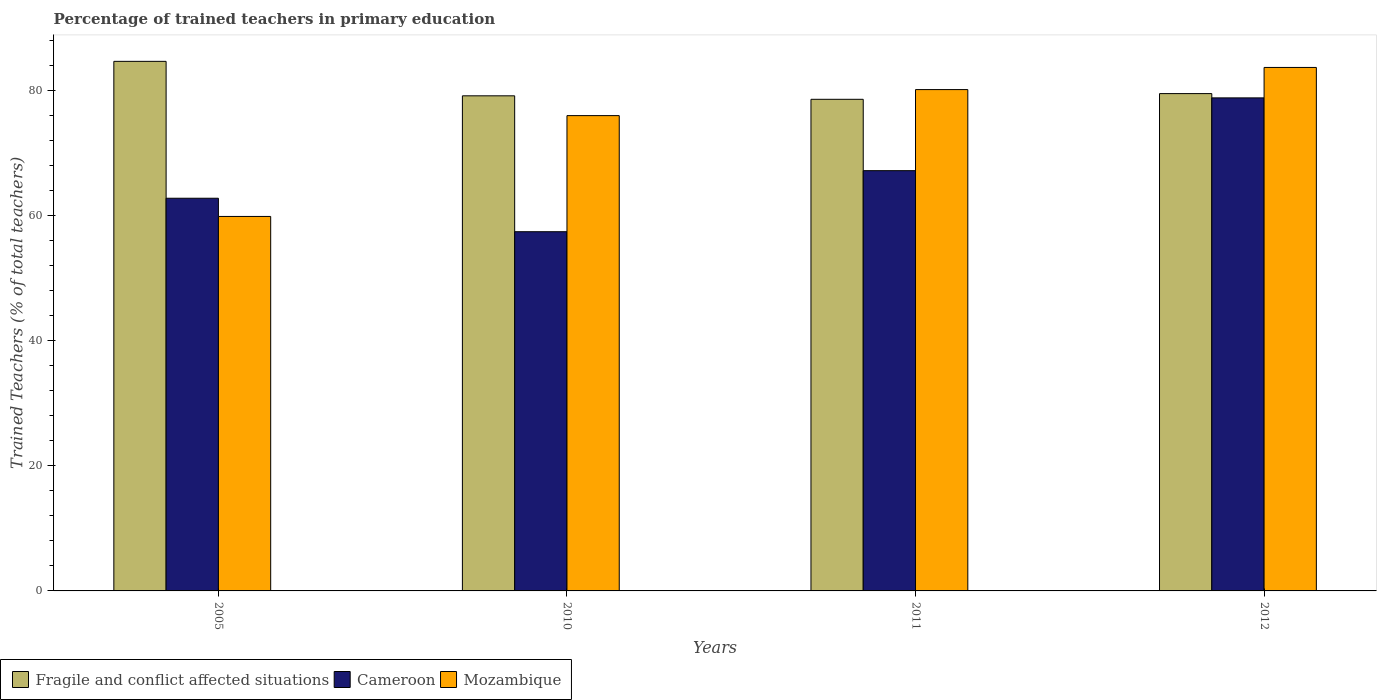How many bars are there on the 2nd tick from the left?
Provide a short and direct response. 3. In how many cases, is the number of bars for a given year not equal to the number of legend labels?
Your response must be concise. 0. What is the percentage of trained teachers in Cameroon in 2005?
Keep it short and to the point. 62.74. Across all years, what is the maximum percentage of trained teachers in Mozambique?
Your response must be concise. 83.64. Across all years, what is the minimum percentage of trained teachers in Fragile and conflict affected situations?
Offer a very short reply. 78.55. In which year was the percentage of trained teachers in Fragile and conflict affected situations minimum?
Offer a terse response. 2011. What is the total percentage of trained teachers in Cameroon in the graph?
Keep it short and to the point. 266.06. What is the difference between the percentage of trained teachers in Fragile and conflict affected situations in 2011 and that in 2012?
Offer a very short reply. -0.91. What is the difference between the percentage of trained teachers in Fragile and conflict affected situations in 2010 and the percentage of trained teachers in Mozambique in 2005?
Offer a terse response. 19.27. What is the average percentage of trained teachers in Mozambique per year?
Provide a short and direct response. 74.88. In the year 2010, what is the difference between the percentage of trained teachers in Mozambique and percentage of trained teachers in Cameroon?
Give a very brief answer. 18.55. In how many years, is the percentage of trained teachers in Mozambique greater than 52 %?
Make the answer very short. 4. What is the ratio of the percentage of trained teachers in Mozambique in 2005 to that in 2011?
Your response must be concise. 0.75. Is the percentage of trained teachers in Cameroon in 2005 less than that in 2010?
Provide a short and direct response. No. Is the difference between the percentage of trained teachers in Mozambique in 2005 and 2012 greater than the difference between the percentage of trained teachers in Cameroon in 2005 and 2012?
Your response must be concise. No. What is the difference between the highest and the second highest percentage of trained teachers in Fragile and conflict affected situations?
Your answer should be very brief. 5.15. What is the difference between the highest and the lowest percentage of trained teachers in Mozambique?
Provide a short and direct response. 23.81. What does the 2nd bar from the left in 2012 represents?
Your response must be concise. Cameroon. What does the 3rd bar from the right in 2011 represents?
Your answer should be compact. Fragile and conflict affected situations. Is it the case that in every year, the sum of the percentage of trained teachers in Mozambique and percentage of trained teachers in Fragile and conflict affected situations is greater than the percentage of trained teachers in Cameroon?
Provide a succinct answer. Yes. How many bars are there?
Give a very brief answer. 12. Are all the bars in the graph horizontal?
Your answer should be compact. No. How many years are there in the graph?
Provide a short and direct response. 4. What is the difference between two consecutive major ticks on the Y-axis?
Offer a terse response. 20. Does the graph contain any zero values?
Make the answer very short. No. Where does the legend appear in the graph?
Keep it short and to the point. Bottom left. What is the title of the graph?
Give a very brief answer. Percentage of trained teachers in primary education. Does "Marshall Islands" appear as one of the legend labels in the graph?
Your answer should be compact. No. What is the label or title of the X-axis?
Your answer should be very brief. Years. What is the label or title of the Y-axis?
Offer a terse response. Trained Teachers (% of total teachers). What is the Trained Teachers (% of total teachers) in Fragile and conflict affected situations in 2005?
Your answer should be very brief. 84.61. What is the Trained Teachers (% of total teachers) of Cameroon in 2005?
Your response must be concise. 62.74. What is the Trained Teachers (% of total teachers) in Mozambique in 2005?
Your response must be concise. 59.83. What is the Trained Teachers (% of total teachers) of Fragile and conflict affected situations in 2010?
Keep it short and to the point. 79.11. What is the Trained Teachers (% of total teachers) of Cameroon in 2010?
Ensure brevity in your answer.  57.39. What is the Trained Teachers (% of total teachers) of Mozambique in 2010?
Your response must be concise. 75.94. What is the Trained Teachers (% of total teachers) of Fragile and conflict affected situations in 2011?
Your answer should be compact. 78.55. What is the Trained Teachers (% of total teachers) of Cameroon in 2011?
Ensure brevity in your answer.  67.15. What is the Trained Teachers (% of total teachers) in Mozambique in 2011?
Give a very brief answer. 80.1. What is the Trained Teachers (% of total teachers) in Fragile and conflict affected situations in 2012?
Your answer should be very brief. 79.46. What is the Trained Teachers (% of total teachers) of Cameroon in 2012?
Make the answer very short. 78.78. What is the Trained Teachers (% of total teachers) in Mozambique in 2012?
Make the answer very short. 83.64. Across all years, what is the maximum Trained Teachers (% of total teachers) of Fragile and conflict affected situations?
Provide a succinct answer. 84.61. Across all years, what is the maximum Trained Teachers (% of total teachers) of Cameroon?
Your answer should be very brief. 78.78. Across all years, what is the maximum Trained Teachers (% of total teachers) of Mozambique?
Your response must be concise. 83.64. Across all years, what is the minimum Trained Teachers (% of total teachers) of Fragile and conflict affected situations?
Make the answer very short. 78.55. Across all years, what is the minimum Trained Teachers (% of total teachers) of Cameroon?
Offer a very short reply. 57.39. Across all years, what is the minimum Trained Teachers (% of total teachers) in Mozambique?
Give a very brief answer. 59.83. What is the total Trained Teachers (% of total teachers) of Fragile and conflict affected situations in the graph?
Ensure brevity in your answer.  321.73. What is the total Trained Teachers (% of total teachers) of Cameroon in the graph?
Ensure brevity in your answer.  266.06. What is the total Trained Teachers (% of total teachers) in Mozambique in the graph?
Give a very brief answer. 299.52. What is the difference between the Trained Teachers (% of total teachers) of Fragile and conflict affected situations in 2005 and that in 2010?
Your answer should be very brief. 5.51. What is the difference between the Trained Teachers (% of total teachers) of Cameroon in 2005 and that in 2010?
Offer a terse response. 5.35. What is the difference between the Trained Teachers (% of total teachers) of Mozambique in 2005 and that in 2010?
Keep it short and to the point. -16.11. What is the difference between the Trained Teachers (% of total teachers) in Fragile and conflict affected situations in 2005 and that in 2011?
Keep it short and to the point. 6.06. What is the difference between the Trained Teachers (% of total teachers) in Cameroon in 2005 and that in 2011?
Ensure brevity in your answer.  -4.41. What is the difference between the Trained Teachers (% of total teachers) of Mozambique in 2005 and that in 2011?
Provide a short and direct response. -20.27. What is the difference between the Trained Teachers (% of total teachers) of Fragile and conflict affected situations in 2005 and that in 2012?
Your response must be concise. 5.15. What is the difference between the Trained Teachers (% of total teachers) in Cameroon in 2005 and that in 2012?
Ensure brevity in your answer.  -16.04. What is the difference between the Trained Teachers (% of total teachers) in Mozambique in 2005 and that in 2012?
Your answer should be compact. -23.81. What is the difference between the Trained Teachers (% of total teachers) in Fragile and conflict affected situations in 2010 and that in 2011?
Offer a terse response. 0.56. What is the difference between the Trained Teachers (% of total teachers) of Cameroon in 2010 and that in 2011?
Offer a terse response. -9.76. What is the difference between the Trained Teachers (% of total teachers) in Mozambique in 2010 and that in 2011?
Provide a succinct answer. -4.16. What is the difference between the Trained Teachers (% of total teachers) of Fragile and conflict affected situations in 2010 and that in 2012?
Provide a short and direct response. -0.36. What is the difference between the Trained Teachers (% of total teachers) of Cameroon in 2010 and that in 2012?
Keep it short and to the point. -21.38. What is the difference between the Trained Teachers (% of total teachers) of Mozambique in 2010 and that in 2012?
Your answer should be compact. -7.7. What is the difference between the Trained Teachers (% of total teachers) of Fragile and conflict affected situations in 2011 and that in 2012?
Give a very brief answer. -0.91. What is the difference between the Trained Teachers (% of total teachers) in Cameroon in 2011 and that in 2012?
Give a very brief answer. -11.63. What is the difference between the Trained Teachers (% of total teachers) in Mozambique in 2011 and that in 2012?
Offer a very short reply. -3.54. What is the difference between the Trained Teachers (% of total teachers) in Fragile and conflict affected situations in 2005 and the Trained Teachers (% of total teachers) in Cameroon in 2010?
Your answer should be compact. 27.22. What is the difference between the Trained Teachers (% of total teachers) in Fragile and conflict affected situations in 2005 and the Trained Teachers (% of total teachers) in Mozambique in 2010?
Your answer should be very brief. 8.67. What is the difference between the Trained Teachers (% of total teachers) of Cameroon in 2005 and the Trained Teachers (% of total teachers) of Mozambique in 2010?
Offer a terse response. -13.2. What is the difference between the Trained Teachers (% of total teachers) of Fragile and conflict affected situations in 2005 and the Trained Teachers (% of total teachers) of Cameroon in 2011?
Give a very brief answer. 17.46. What is the difference between the Trained Teachers (% of total teachers) of Fragile and conflict affected situations in 2005 and the Trained Teachers (% of total teachers) of Mozambique in 2011?
Make the answer very short. 4.51. What is the difference between the Trained Teachers (% of total teachers) in Cameroon in 2005 and the Trained Teachers (% of total teachers) in Mozambique in 2011?
Offer a very short reply. -17.36. What is the difference between the Trained Teachers (% of total teachers) in Fragile and conflict affected situations in 2005 and the Trained Teachers (% of total teachers) in Cameroon in 2012?
Keep it short and to the point. 5.84. What is the difference between the Trained Teachers (% of total teachers) of Fragile and conflict affected situations in 2005 and the Trained Teachers (% of total teachers) of Mozambique in 2012?
Make the answer very short. 0.97. What is the difference between the Trained Teachers (% of total teachers) in Cameroon in 2005 and the Trained Teachers (% of total teachers) in Mozambique in 2012?
Your response must be concise. -20.9. What is the difference between the Trained Teachers (% of total teachers) in Fragile and conflict affected situations in 2010 and the Trained Teachers (% of total teachers) in Cameroon in 2011?
Ensure brevity in your answer.  11.96. What is the difference between the Trained Teachers (% of total teachers) of Fragile and conflict affected situations in 2010 and the Trained Teachers (% of total teachers) of Mozambique in 2011?
Keep it short and to the point. -1. What is the difference between the Trained Teachers (% of total teachers) in Cameroon in 2010 and the Trained Teachers (% of total teachers) in Mozambique in 2011?
Provide a succinct answer. -22.71. What is the difference between the Trained Teachers (% of total teachers) in Fragile and conflict affected situations in 2010 and the Trained Teachers (% of total teachers) in Cameroon in 2012?
Make the answer very short. 0.33. What is the difference between the Trained Teachers (% of total teachers) of Fragile and conflict affected situations in 2010 and the Trained Teachers (% of total teachers) of Mozambique in 2012?
Keep it short and to the point. -4.53. What is the difference between the Trained Teachers (% of total teachers) in Cameroon in 2010 and the Trained Teachers (% of total teachers) in Mozambique in 2012?
Provide a succinct answer. -26.25. What is the difference between the Trained Teachers (% of total teachers) of Fragile and conflict affected situations in 2011 and the Trained Teachers (% of total teachers) of Cameroon in 2012?
Your answer should be compact. -0.23. What is the difference between the Trained Teachers (% of total teachers) of Fragile and conflict affected situations in 2011 and the Trained Teachers (% of total teachers) of Mozambique in 2012?
Your response must be concise. -5.09. What is the difference between the Trained Teachers (% of total teachers) in Cameroon in 2011 and the Trained Teachers (% of total teachers) in Mozambique in 2012?
Provide a short and direct response. -16.49. What is the average Trained Teachers (% of total teachers) in Fragile and conflict affected situations per year?
Your answer should be very brief. 80.43. What is the average Trained Teachers (% of total teachers) in Cameroon per year?
Your response must be concise. 66.52. What is the average Trained Teachers (% of total teachers) in Mozambique per year?
Offer a very short reply. 74.88. In the year 2005, what is the difference between the Trained Teachers (% of total teachers) in Fragile and conflict affected situations and Trained Teachers (% of total teachers) in Cameroon?
Provide a succinct answer. 21.87. In the year 2005, what is the difference between the Trained Teachers (% of total teachers) in Fragile and conflict affected situations and Trained Teachers (% of total teachers) in Mozambique?
Give a very brief answer. 24.78. In the year 2005, what is the difference between the Trained Teachers (% of total teachers) of Cameroon and Trained Teachers (% of total teachers) of Mozambique?
Your answer should be compact. 2.91. In the year 2010, what is the difference between the Trained Teachers (% of total teachers) of Fragile and conflict affected situations and Trained Teachers (% of total teachers) of Cameroon?
Offer a terse response. 21.71. In the year 2010, what is the difference between the Trained Teachers (% of total teachers) of Fragile and conflict affected situations and Trained Teachers (% of total teachers) of Mozambique?
Keep it short and to the point. 3.16. In the year 2010, what is the difference between the Trained Teachers (% of total teachers) in Cameroon and Trained Teachers (% of total teachers) in Mozambique?
Your response must be concise. -18.55. In the year 2011, what is the difference between the Trained Teachers (% of total teachers) of Fragile and conflict affected situations and Trained Teachers (% of total teachers) of Cameroon?
Ensure brevity in your answer.  11.4. In the year 2011, what is the difference between the Trained Teachers (% of total teachers) of Fragile and conflict affected situations and Trained Teachers (% of total teachers) of Mozambique?
Offer a terse response. -1.55. In the year 2011, what is the difference between the Trained Teachers (% of total teachers) in Cameroon and Trained Teachers (% of total teachers) in Mozambique?
Give a very brief answer. -12.95. In the year 2012, what is the difference between the Trained Teachers (% of total teachers) in Fragile and conflict affected situations and Trained Teachers (% of total teachers) in Cameroon?
Your response must be concise. 0.68. In the year 2012, what is the difference between the Trained Teachers (% of total teachers) in Fragile and conflict affected situations and Trained Teachers (% of total teachers) in Mozambique?
Offer a very short reply. -4.18. In the year 2012, what is the difference between the Trained Teachers (% of total teachers) of Cameroon and Trained Teachers (% of total teachers) of Mozambique?
Give a very brief answer. -4.86. What is the ratio of the Trained Teachers (% of total teachers) in Fragile and conflict affected situations in 2005 to that in 2010?
Provide a succinct answer. 1.07. What is the ratio of the Trained Teachers (% of total teachers) of Cameroon in 2005 to that in 2010?
Your response must be concise. 1.09. What is the ratio of the Trained Teachers (% of total teachers) in Mozambique in 2005 to that in 2010?
Provide a short and direct response. 0.79. What is the ratio of the Trained Teachers (% of total teachers) in Fragile and conflict affected situations in 2005 to that in 2011?
Offer a very short reply. 1.08. What is the ratio of the Trained Teachers (% of total teachers) in Cameroon in 2005 to that in 2011?
Provide a short and direct response. 0.93. What is the ratio of the Trained Teachers (% of total teachers) in Mozambique in 2005 to that in 2011?
Your answer should be compact. 0.75. What is the ratio of the Trained Teachers (% of total teachers) in Fragile and conflict affected situations in 2005 to that in 2012?
Ensure brevity in your answer.  1.06. What is the ratio of the Trained Teachers (% of total teachers) in Cameroon in 2005 to that in 2012?
Make the answer very short. 0.8. What is the ratio of the Trained Teachers (% of total teachers) of Mozambique in 2005 to that in 2012?
Give a very brief answer. 0.72. What is the ratio of the Trained Teachers (% of total teachers) in Fragile and conflict affected situations in 2010 to that in 2011?
Give a very brief answer. 1.01. What is the ratio of the Trained Teachers (% of total teachers) in Cameroon in 2010 to that in 2011?
Provide a succinct answer. 0.85. What is the ratio of the Trained Teachers (% of total teachers) of Mozambique in 2010 to that in 2011?
Provide a short and direct response. 0.95. What is the ratio of the Trained Teachers (% of total teachers) in Fragile and conflict affected situations in 2010 to that in 2012?
Ensure brevity in your answer.  1. What is the ratio of the Trained Teachers (% of total teachers) of Cameroon in 2010 to that in 2012?
Your answer should be very brief. 0.73. What is the ratio of the Trained Teachers (% of total teachers) of Mozambique in 2010 to that in 2012?
Offer a very short reply. 0.91. What is the ratio of the Trained Teachers (% of total teachers) in Fragile and conflict affected situations in 2011 to that in 2012?
Your response must be concise. 0.99. What is the ratio of the Trained Teachers (% of total teachers) in Cameroon in 2011 to that in 2012?
Your answer should be very brief. 0.85. What is the ratio of the Trained Teachers (% of total teachers) in Mozambique in 2011 to that in 2012?
Offer a very short reply. 0.96. What is the difference between the highest and the second highest Trained Teachers (% of total teachers) of Fragile and conflict affected situations?
Provide a short and direct response. 5.15. What is the difference between the highest and the second highest Trained Teachers (% of total teachers) of Cameroon?
Offer a very short reply. 11.63. What is the difference between the highest and the second highest Trained Teachers (% of total teachers) of Mozambique?
Offer a terse response. 3.54. What is the difference between the highest and the lowest Trained Teachers (% of total teachers) in Fragile and conflict affected situations?
Keep it short and to the point. 6.06. What is the difference between the highest and the lowest Trained Teachers (% of total teachers) of Cameroon?
Provide a succinct answer. 21.38. What is the difference between the highest and the lowest Trained Teachers (% of total teachers) of Mozambique?
Offer a terse response. 23.81. 